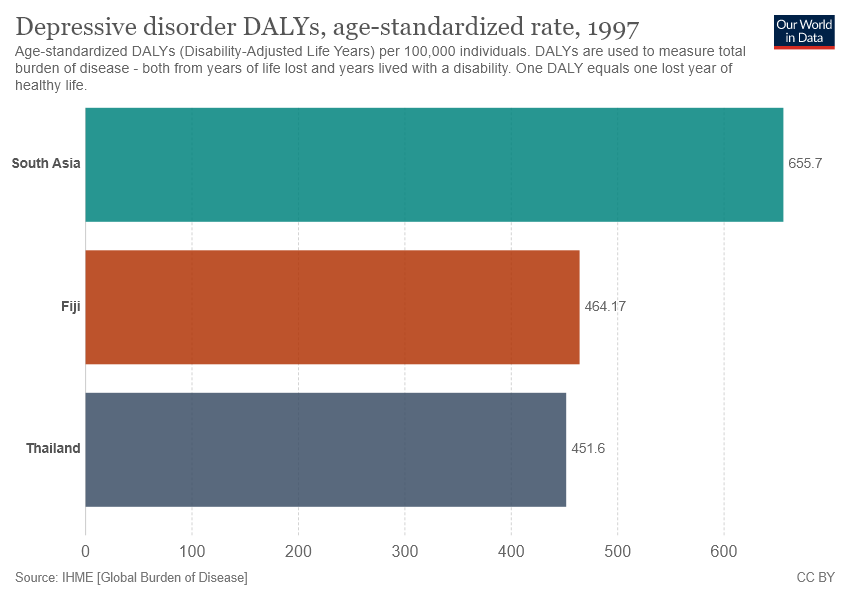Mention a couple of crucial points in this snapshot. Fiji has a value of 464.17. The average of Fiji and Thailand is 457.885... 